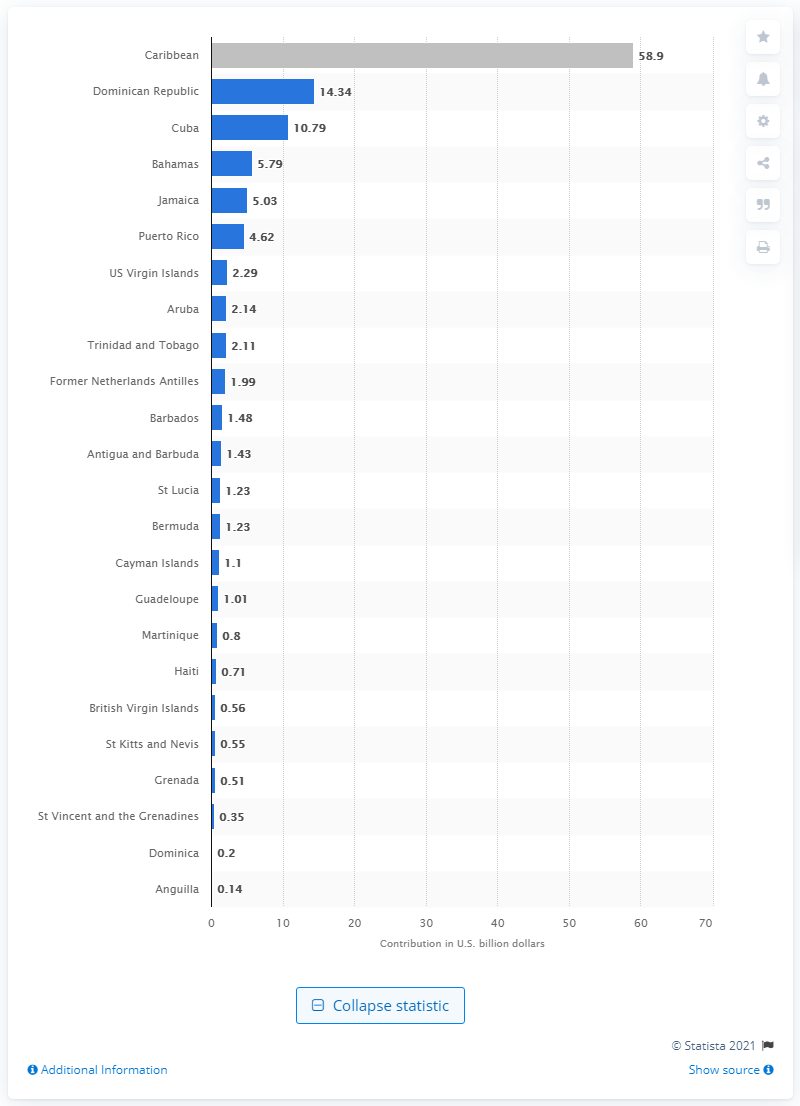Point out several critical features in this image. In 2019, the travel and tourism sector made a total contribution of 58.9% to the Caribbean's Gross Domestic Product (GDP). In 2019, the travel and tourism sector contributed 58.9% to the gross domestic product of the Caribbean region. 